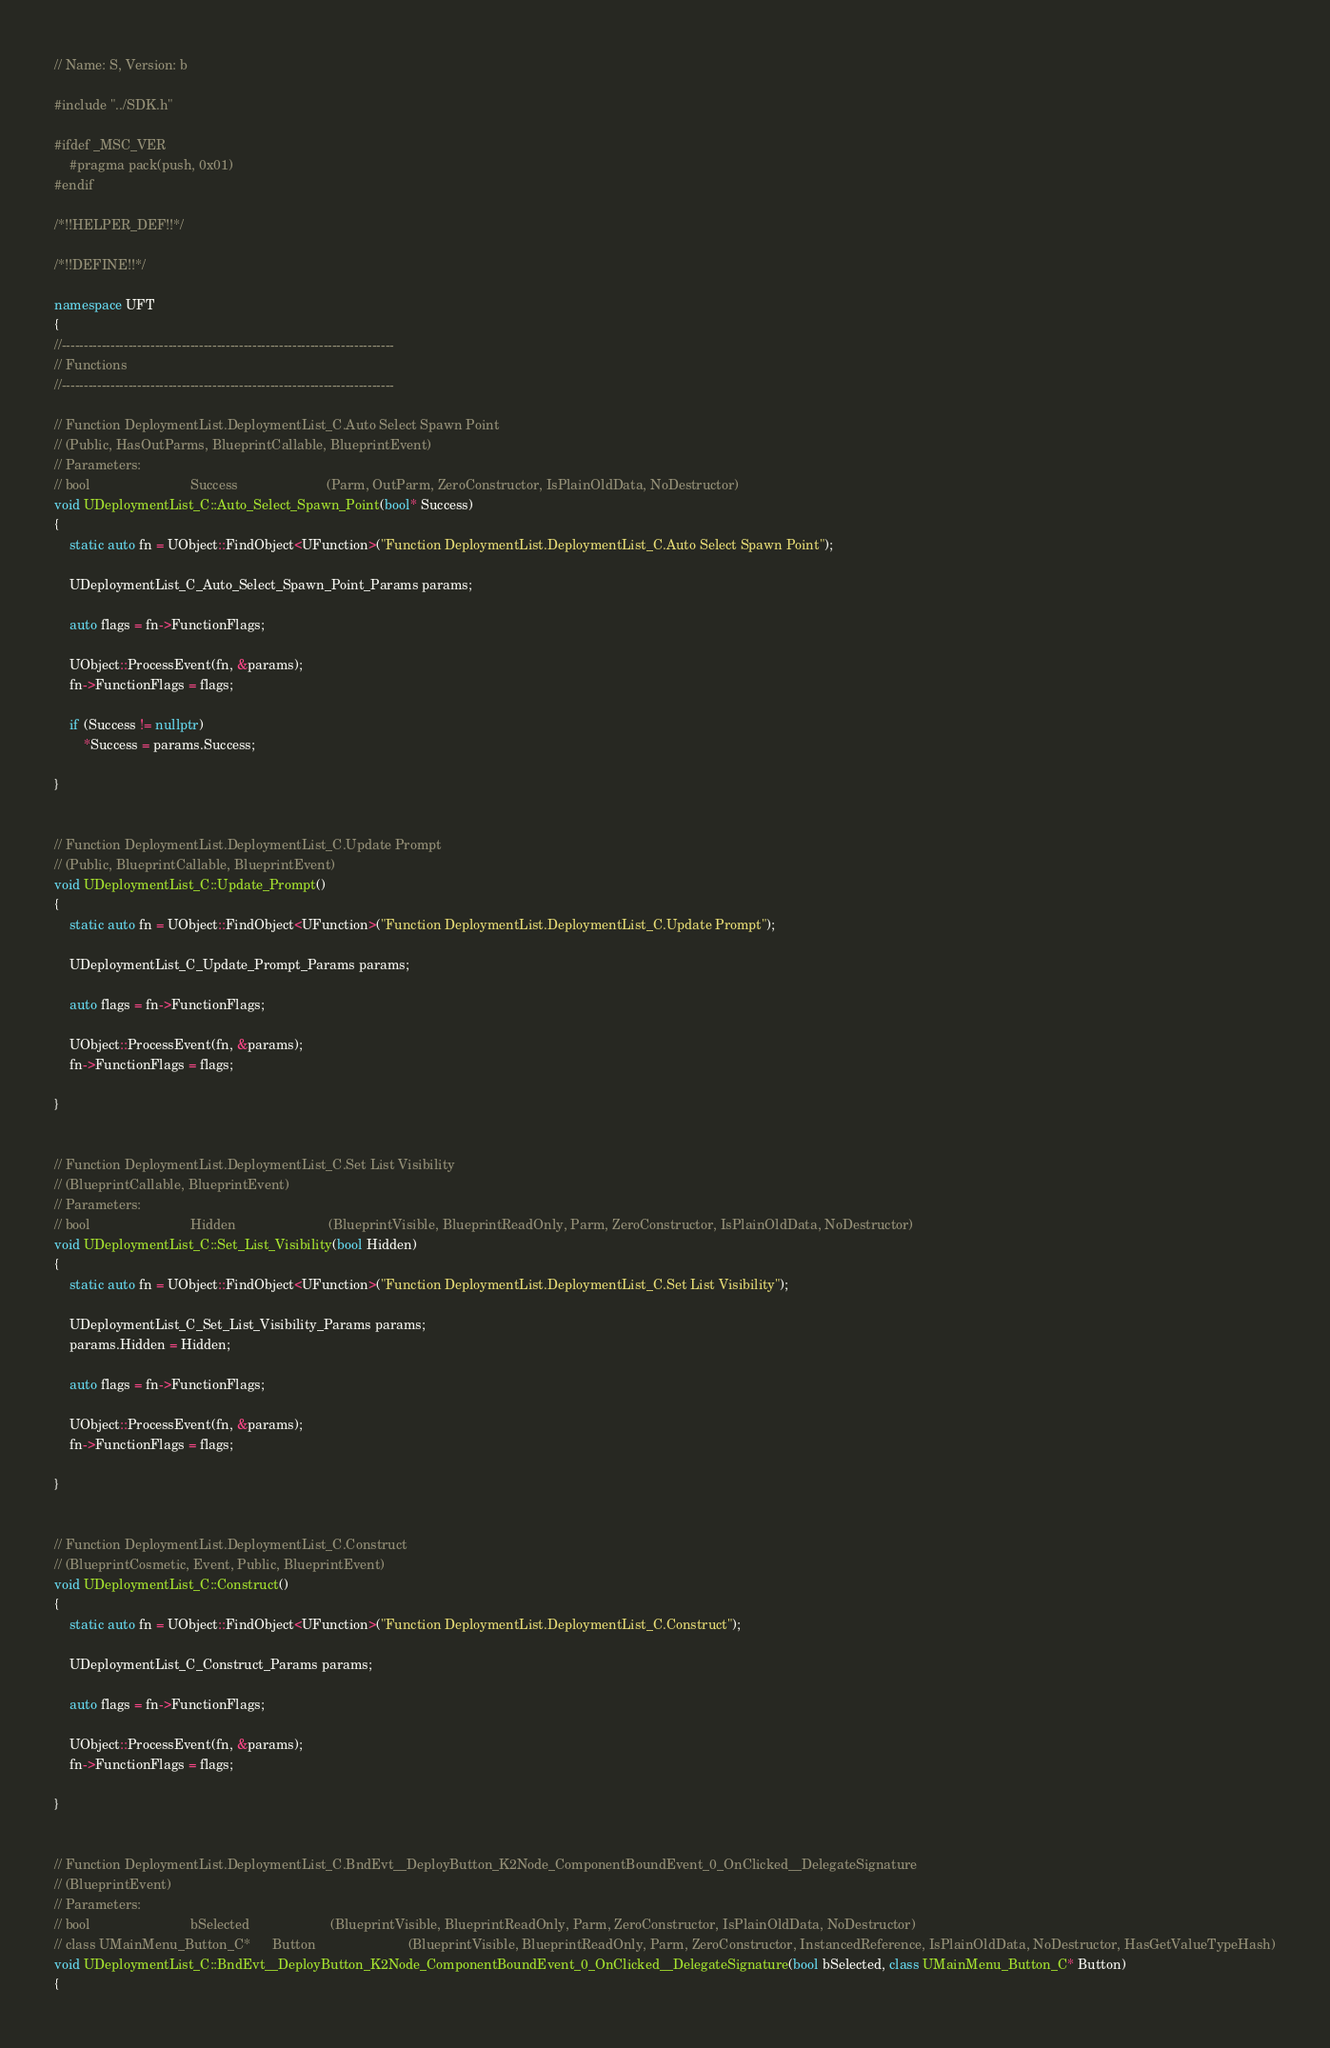Convert code to text. <code><loc_0><loc_0><loc_500><loc_500><_C++_>// Name: S, Version: b

#include "../SDK.h"

#ifdef _MSC_VER
	#pragma pack(push, 0x01)
#endif

/*!!HELPER_DEF!!*/

/*!!DEFINE!!*/

namespace UFT
{
//---------------------------------------------------------------------------
// Functions
//---------------------------------------------------------------------------

// Function DeploymentList.DeploymentList_C.Auto Select Spawn Point
// (Public, HasOutParms, BlueprintCallable, BlueprintEvent)
// Parameters:
// bool                           Success                        (Parm, OutParm, ZeroConstructor, IsPlainOldData, NoDestructor)
void UDeploymentList_C::Auto_Select_Spawn_Point(bool* Success)
{
	static auto fn = UObject::FindObject<UFunction>("Function DeploymentList.DeploymentList_C.Auto Select Spawn Point");

	UDeploymentList_C_Auto_Select_Spawn_Point_Params params;

	auto flags = fn->FunctionFlags;

	UObject::ProcessEvent(fn, &params);
	fn->FunctionFlags = flags;

	if (Success != nullptr)
		*Success = params.Success;

}


// Function DeploymentList.DeploymentList_C.Update Prompt
// (Public, BlueprintCallable, BlueprintEvent)
void UDeploymentList_C::Update_Prompt()
{
	static auto fn = UObject::FindObject<UFunction>("Function DeploymentList.DeploymentList_C.Update Prompt");

	UDeploymentList_C_Update_Prompt_Params params;

	auto flags = fn->FunctionFlags;

	UObject::ProcessEvent(fn, &params);
	fn->FunctionFlags = flags;

}


// Function DeploymentList.DeploymentList_C.Set List Visibility
// (BlueprintCallable, BlueprintEvent)
// Parameters:
// bool                           Hidden                         (BlueprintVisible, BlueprintReadOnly, Parm, ZeroConstructor, IsPlainOldData, NoDestructor)
void UDeploymentList_C::Set_List_Visibility(bool Hidden)
{
	static auto fn = UObject::FindObject<UFunction>("Function DeploymentList.DeploymentList_C.Set List Visibility");

	UDeploymentList_C_Set_List_Visibility_Params params;
	params.Hidden = Hidden;

	auto flags = fn->FunctionFlags;

	UObject::ProcessEvent(fn, &params);
	fn->FunctionFlags = flags;

}


// Function DeploymentList.DeploymentList_C.Construct
// (BlueprintCosmetic, Event, Public, BlueprintEvent)
void UDeploymentList_C::Construct()
{
	static auto fn = UObject::FindObject<UFunction>("Function DeploymentList.DeploymentList_C.Construct");

	UDeploymentList_C_Construct_Params params;

	auto flags = fn->FunctionFlags;

	UObject::ProcessEvent(fn, &params);
	fn->FunctionFlags = flags;

}


// Function DeploymentList.DeploymentList_C.BndEvt__DeployButton_K2Node_ComponentBoundEvent_0_OnClicked__DelegateSignature
// (BlueprintEvent)
// Parameters:
// bool                           bSelected                      (BlueprintVisible, BlueprintReadOnly, Parm, ZeroConstructor, IsPlainOldData, NoDestructor)
// class UMainMenu_Button_C*      Button                         (BlueprintVisible, BlueprintReadOnly, Parm, ZeroConstructor, InstancedReference, IsPlainOldData, NoDestructor, HasGetValueTypeHash)
void UDeploymentList_C::BndEvt__DeployButton_K2Node_ComponentBoundEvent_0_OnClicked__DelegateSignature(bool bSelected, class UMainMenu_Button_C* Button)
{</code> 